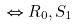Convert formula to latex. <formula><loc_0><loc_0><loc_500><loc_500>\Leftrightarrow R _ { 0 } , S _ { 1 }</formula> 